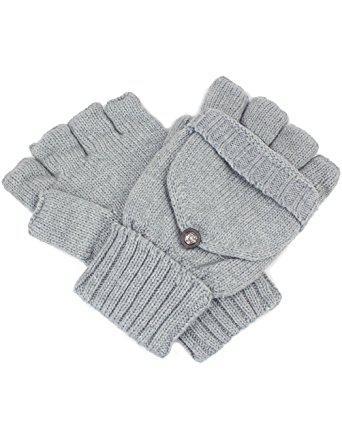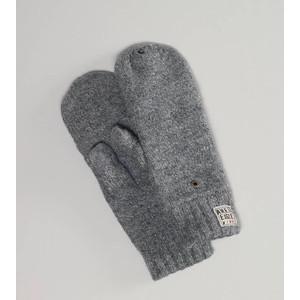The first image is the image on the left, the second image is the image on the right. Given the left and right images, does the statement "All mittens shown have rounded tops without fingers, and the knitted mitten pair on the left is a solid color with a diamond pattern." hold true? Answer yes or no. No. The first image is the image on the left, the second image is the image on the right. Examine the images to the left and right. Is the description "One pair of gloves is dark grey." accurate? Answer yes or no. Yes. 